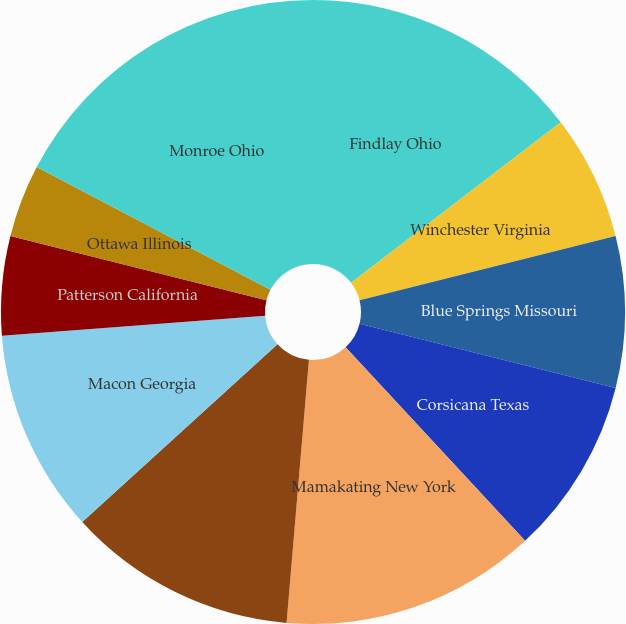Convert chart to OTSL. <chart><loc_0><loc_0><loc_500><loc_500><pie_chart><fcel>Findlay Ohio<fcel>Winchester Virginia<fcel>Blue Springs Missouri<fcel>Corsicana Texas<fcel>Mamakating New York<fcel>San Bernardino California<fcel>Macon Georgia<fcel>Patterson California<fcel>Ottawa Illinois<fcel>Monroe Ohio<nl><fcel>14.6%<fcel>6.48%<fcel>7.83%<fcel>9.19%<fcel>13.25%<fcel>11.9%<fcel>10.54%<fcel>5.13%<fcel>3.77%<fcel>17.31%<nl></chart> 